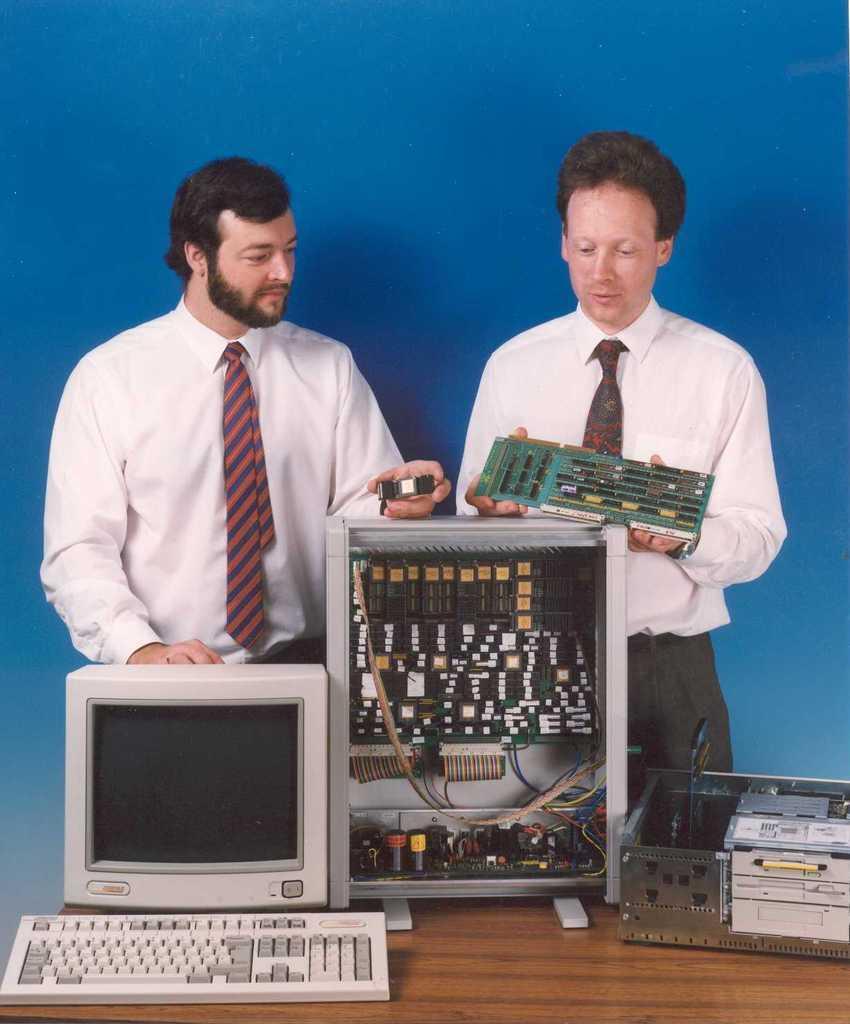How would you summarize this image in a sentence or two? In this image I can see two men are standing and I can see both of them are wearing white shirt and tie. I can also see both of them are holding few green colour things. Here I can see a table and on it I can see a white colour monitor, keyboard, CPU and an electronic device. I can also see blue colour in background. 